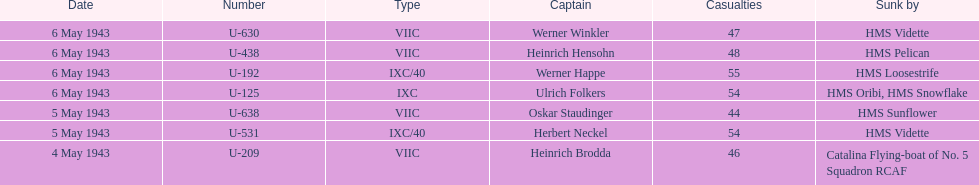How many more casualties occurred on may 6 compared to may 4? 158. 